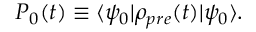Convert formula to latex. <formula><loc_0><loc_0><loc_500><loc_500>\begin{array} { r } { P _ { 0 } ( t ) \equiv \langle \psi _ { 0 } | \rho _ { p r e } ( t ) | \psi _ { 0 } \rangle . } \end{array}</formula> 